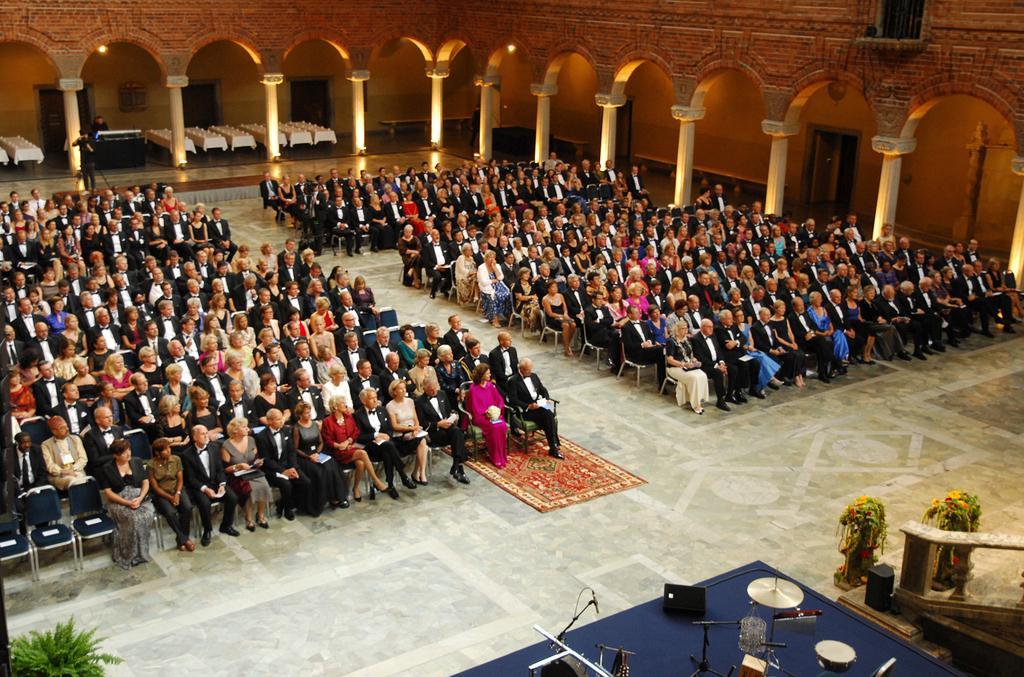Can you describe this image briefly? In this image a group of people sitting on chairs, around them there are pillars, on the right side there are drums and mic, on the left side there is a plant. 